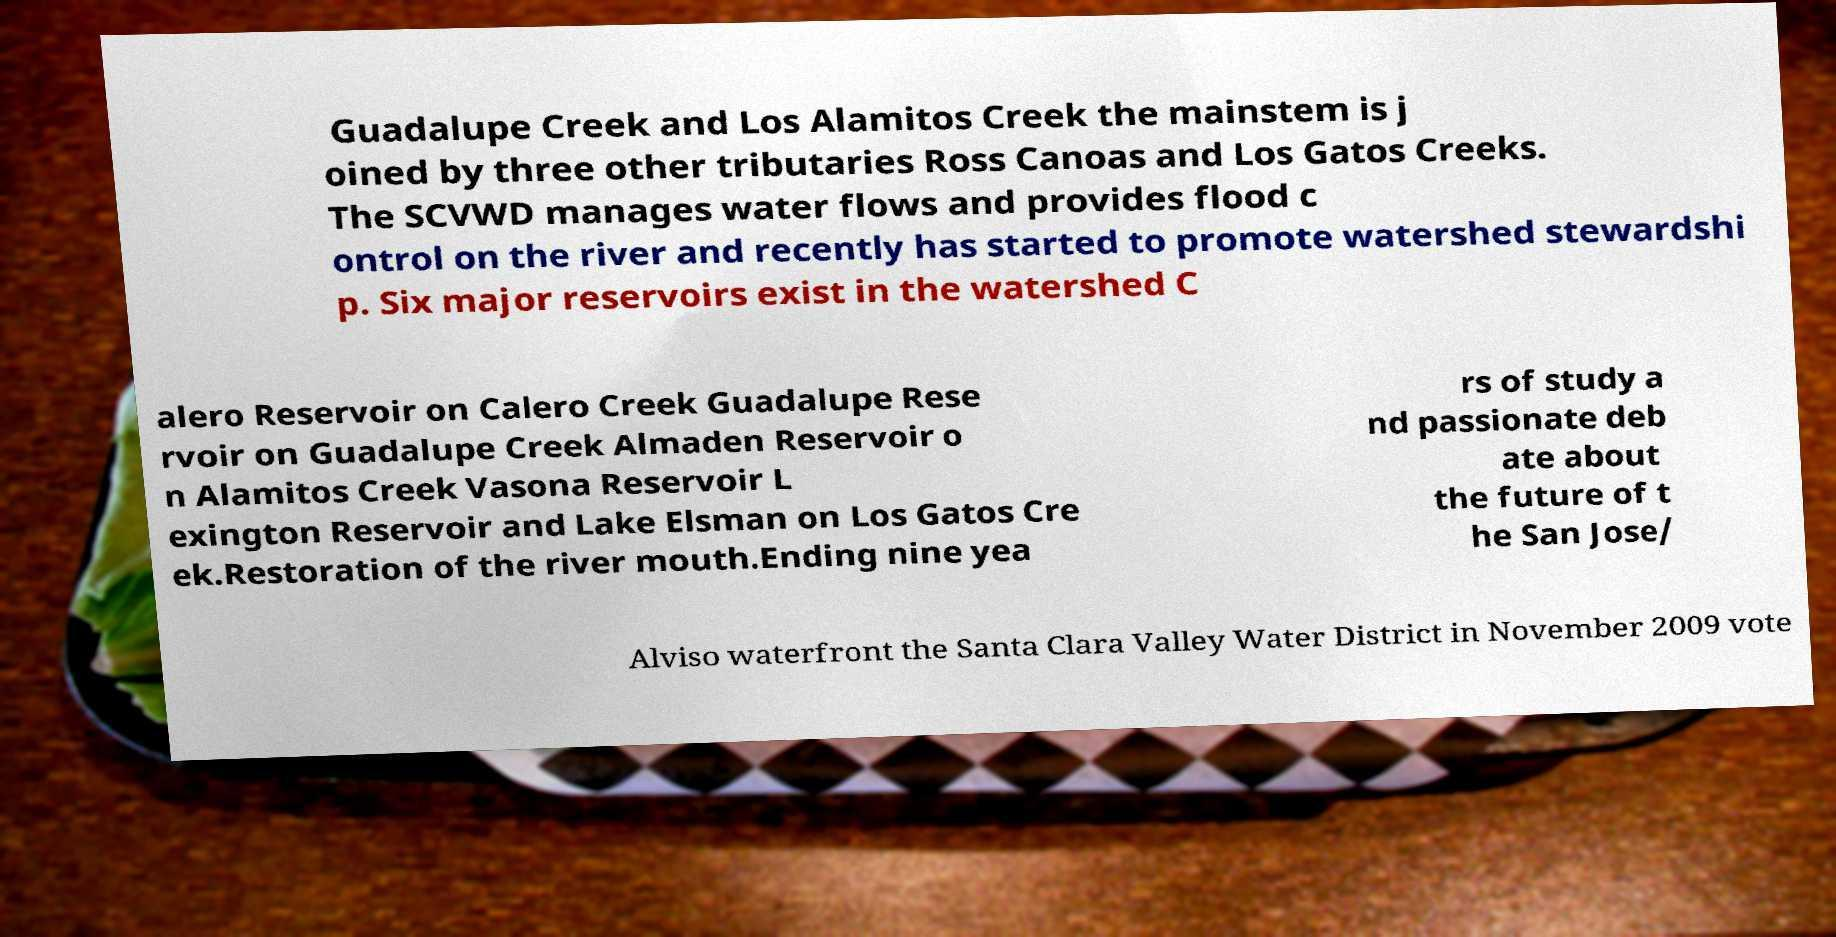Please identify and transcribe the text found in this image. Guadalupe Creek and Los Alamitos Creek the mainstem is j oined by three other tributaries Ross Canoas and Los Gatos Creeks. The SCVWD manages water flows and provides flood c ontrol on the river and recently has started to promote watershed stewardshi p. Six major reservoirs exist in the watershed C alero Reservoir on Calero Creek Guadalupe Rese rvoir on Guadalupe Creek Almaden Reservoir o n Alamitos Creek Vasona Reservoir L exington Reservoir and Lake Elsman on Los Gatos Cre ek.Restoration of the river mouth.Ending nine yea rs of study a nd passionate deb ate about the future of t he San Jose/ Alviso waterfront the Santa Clara Valley Water District in November 2009 vote 